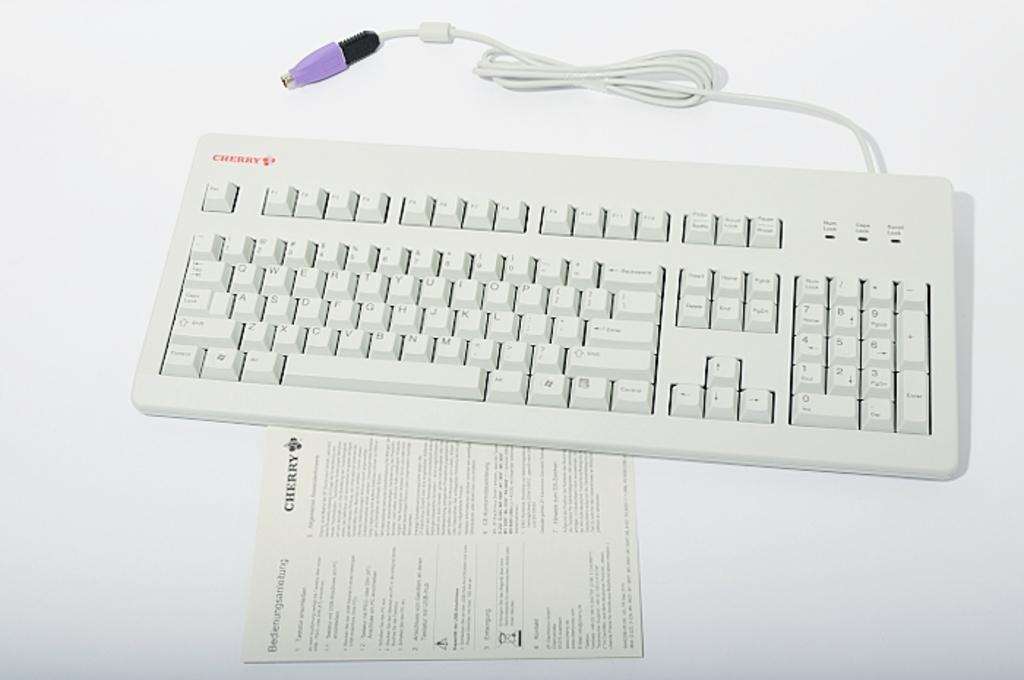<image>
Describe the image concisely. A white computer keyboard has the word Cherry written on the instructions and the product. 